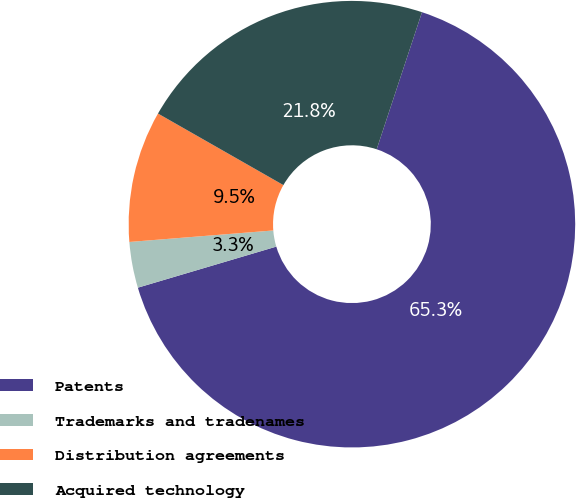<chart> <loc_0><loc_0><loc_500><loc_500><pie_chart><fcel>Patents<fcel>Trademarks and tradenames<fcel>Distribution agreements<fcel>Acquired technology<nl><fcel>65.33%<fcel>3.32%<fcel>9.52%<fcel>21.83%<nl></chart> 